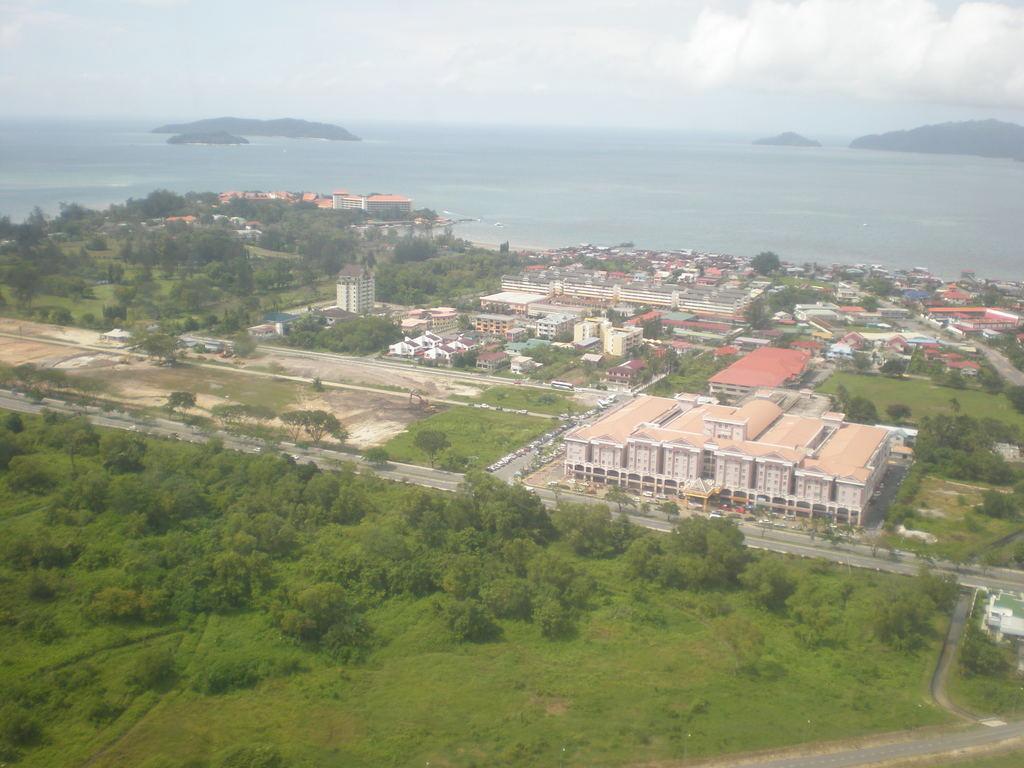Describe this image in one or two sentences. This is an Aerial view image of a place which consists of building, houses, trees, roads, sea, and mountains. 